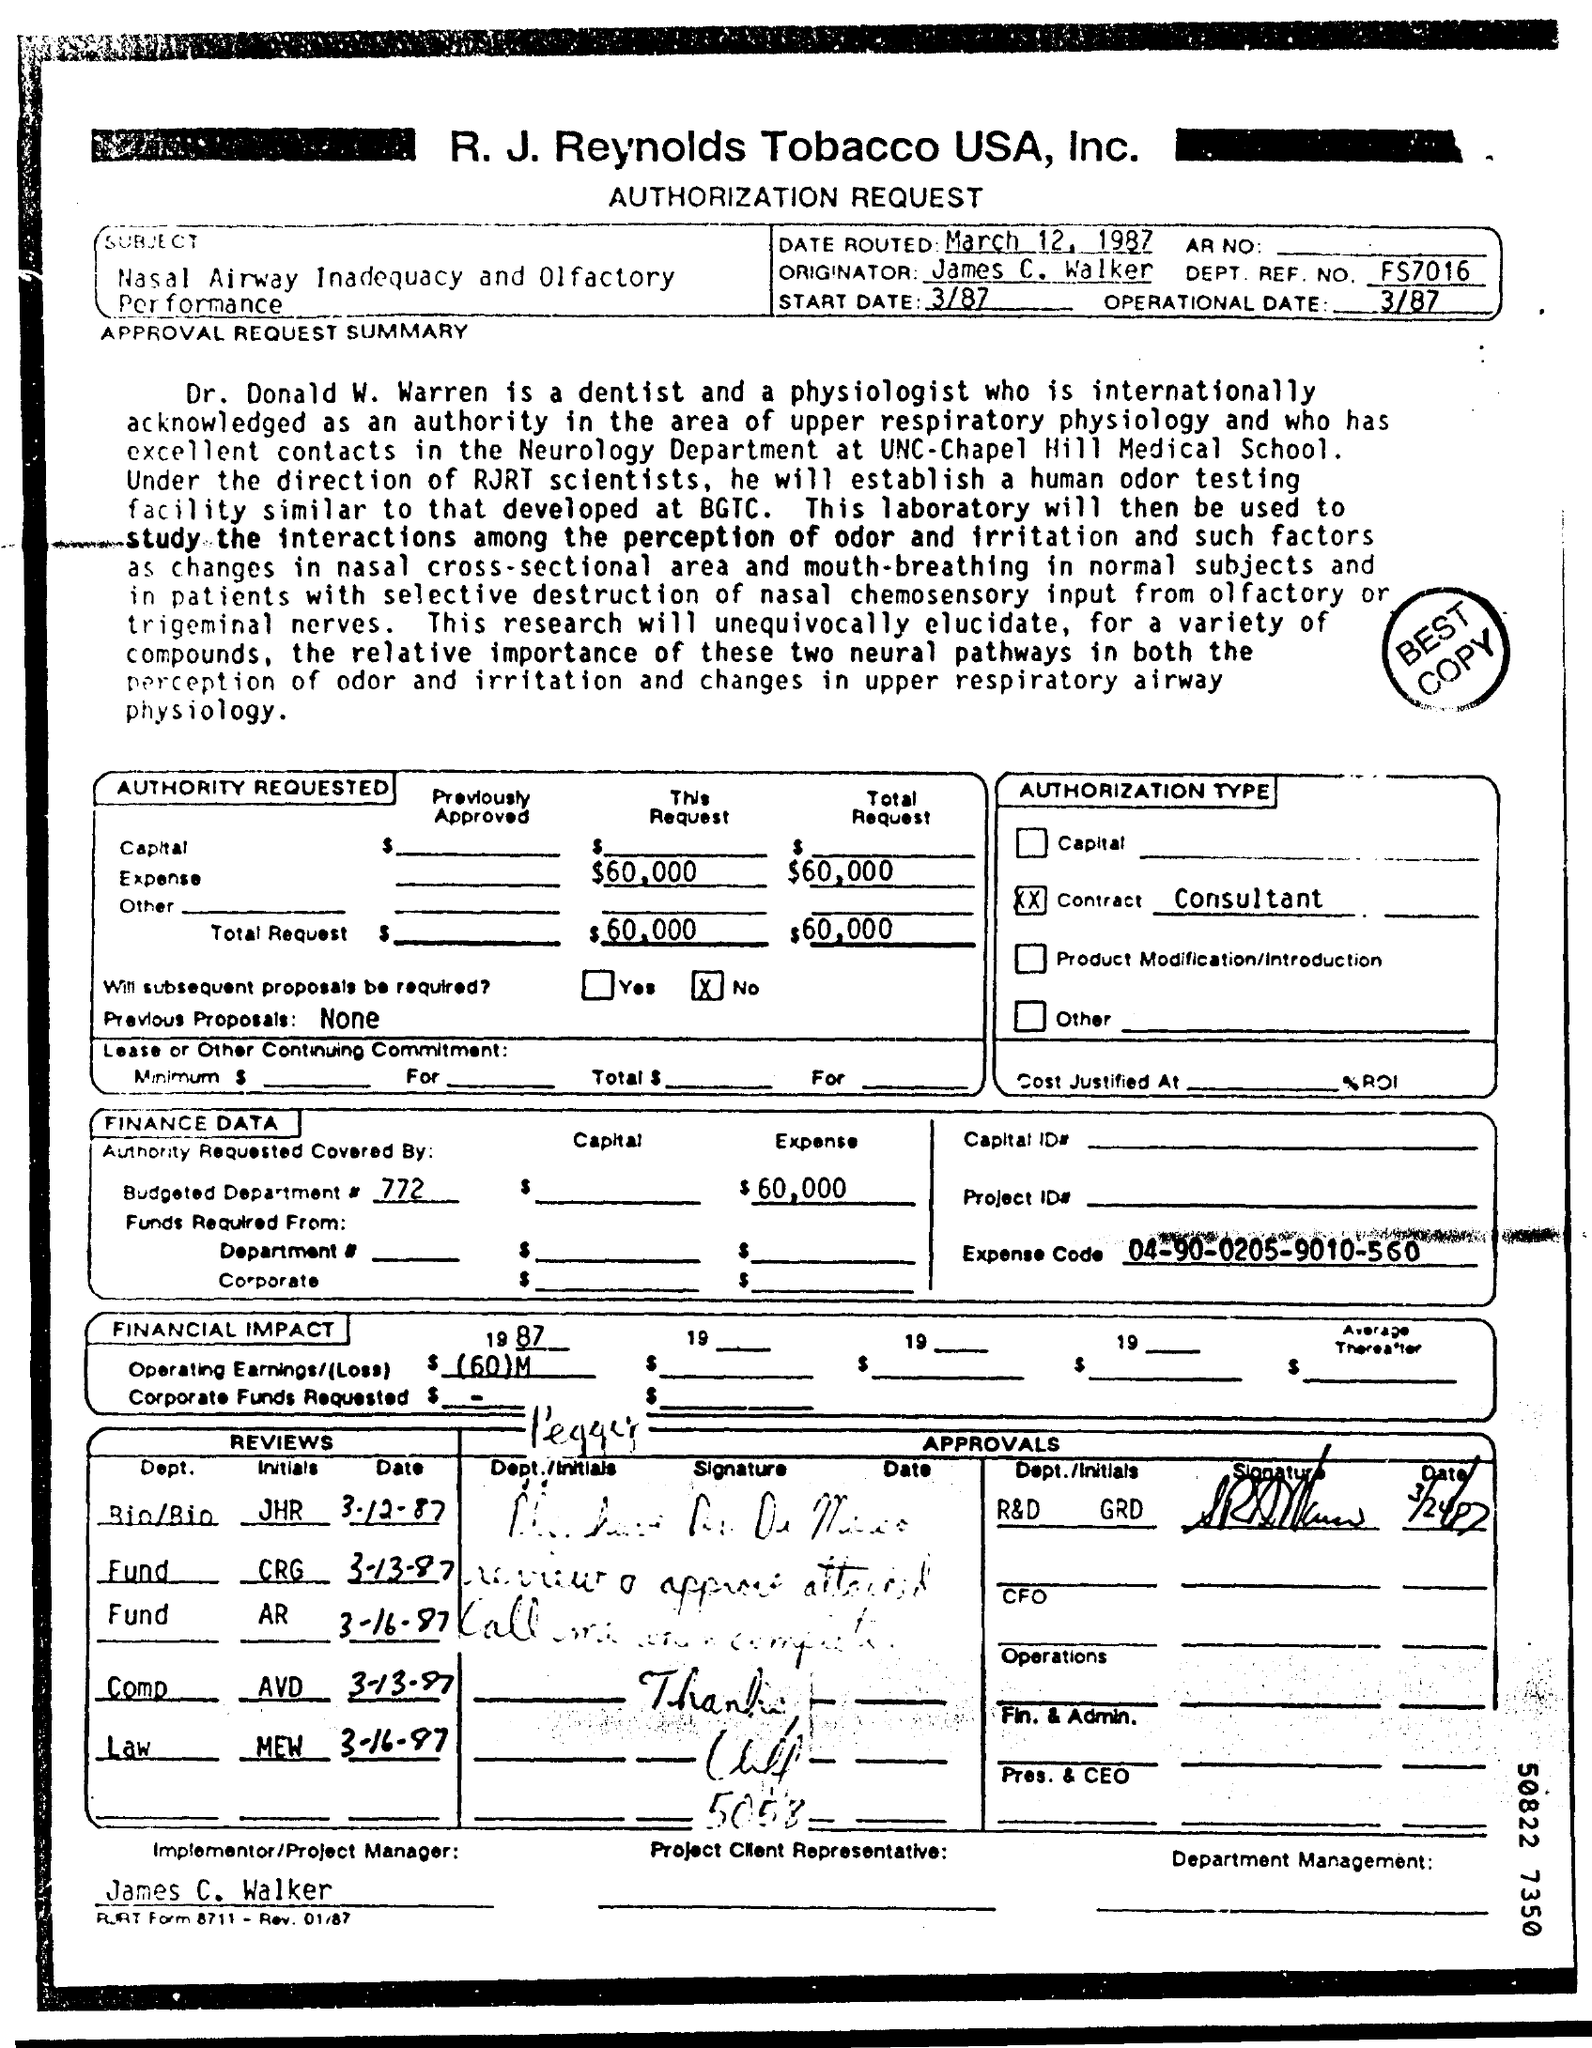Highlight a few significant elements in this photo. The subject of the letter is nasal airway inadequacy and olfactory performance. Dr. Donald W Warren is a dentist and physiologist by profession. James C. Walker is the implementer and project manager for the task at hand. 